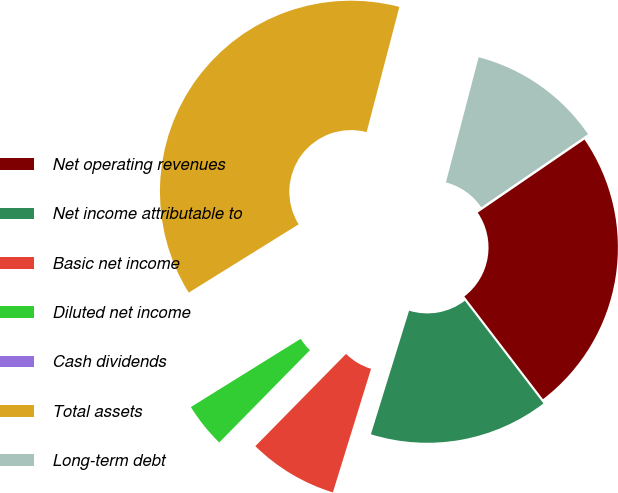<chart> <loc_0><loc_0><loc_500><loc_500><pie_chart><fcel>Net operating revenues<fcel>Net income attributable to<fcel>Basic net income<fcel>Diluted net income<fcel>Cash dividends<fcel>Total assets<fcel>Long-term debt<nl><fcel>24.15%<fcel>15.17%<fcel>7.59%<fcel>3.79%<fcel>0.0%<fcel>37.92%<fcel>11.38%<nl></chart> 